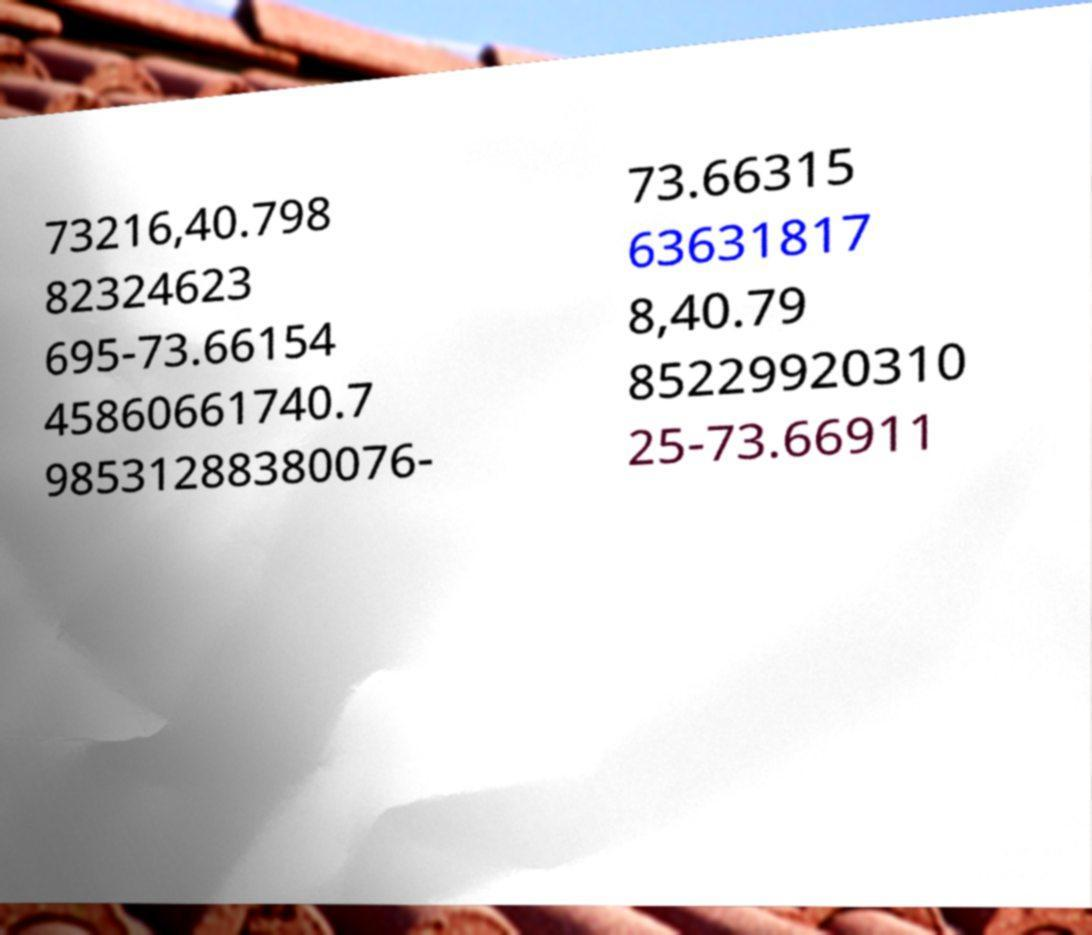Could you extract and type out the text from this image? 73216,40.798 82324623 695-73.66154 45860661740.7 98531288380076- 73.66315 63631817 8,40.79 85229920310 25-73.66911 